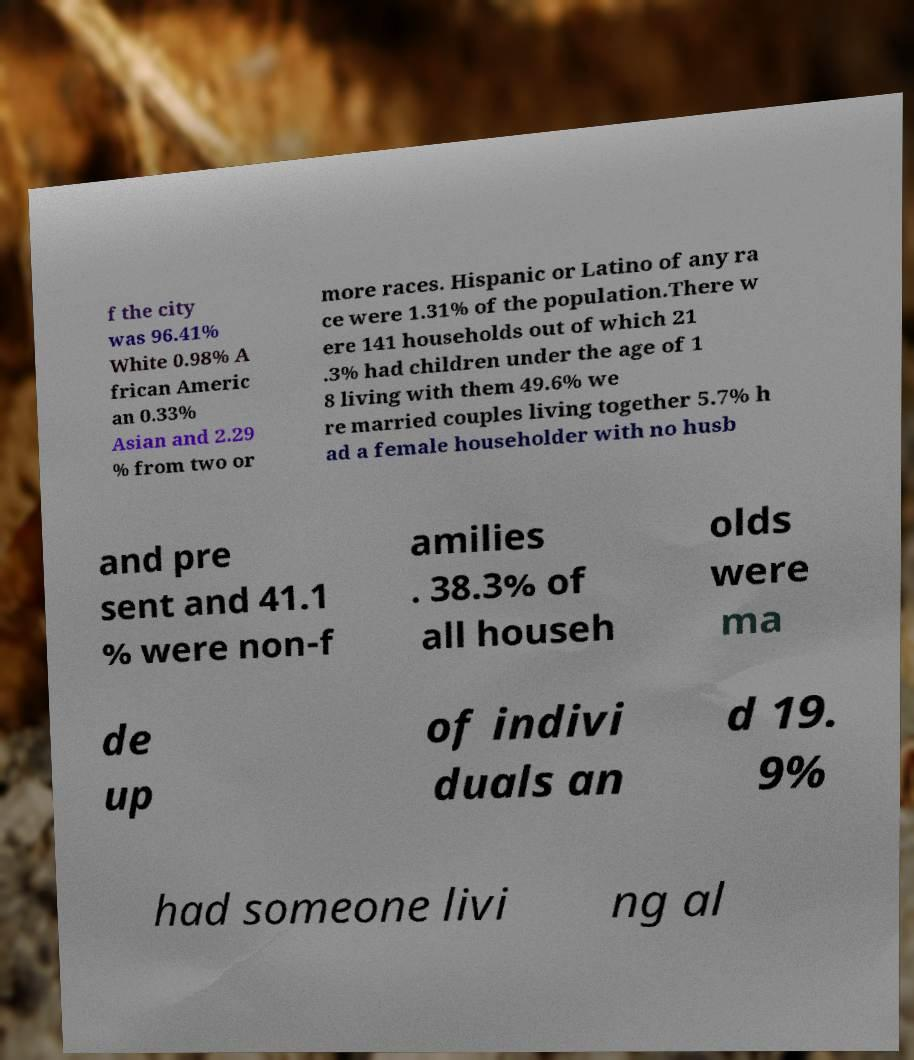I need the written content from this picture converted into text. Can you do that? f the city was 96.41% White 0.98% A frican Americ an 0.33% Asian and 2.29 % from two or more races. Hispanic or Latino of any ra ce were 1.31% of the population.There w ere 141 households out of which 21 .3% had children under the age of 1 8 living with them 49.6% we re married couples living together 5.7% h ad a female householder with no husb and pre sent and 41.1 % were non-f amilies . 38.3% of all househ olds were ma de up of indivi duals an d 19. 9% had someone livi ng al 